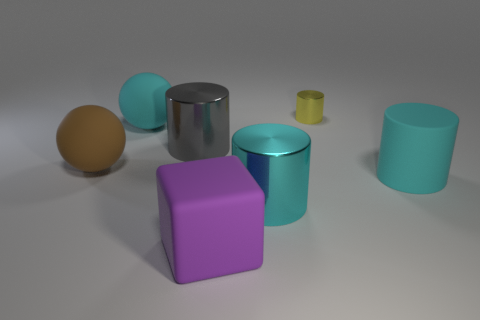Could you guess the material of the small yellow object, and how does its size compare to the others? The small yellow object appears to have a matte finish, suggesting it could be made from a plastic or painted wood. It is significantly smaller than the other objects and is cylindrical in shape, resembling a small container or a cup. 